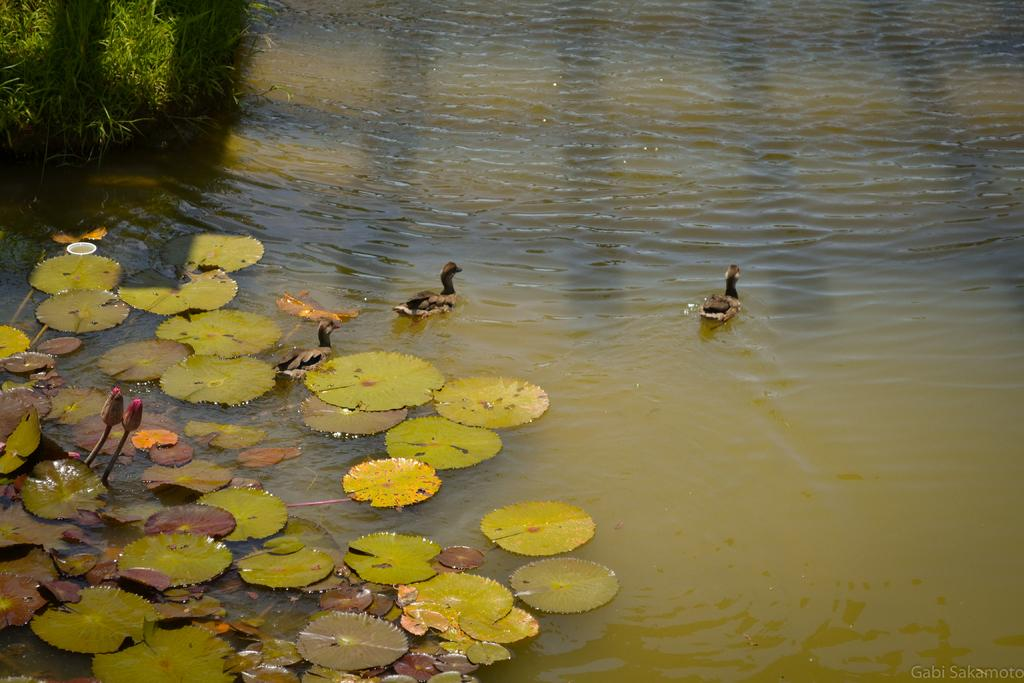What type of animals can be seen in the image? There are ducks in the water in the image. What else can be seen floating on the water? There are leaves and flower buds on the water. What type of vegetation is visible in the image? There is grass visible in the image. Is there any text or logo visible on the image? Yes, the image has a watermark. What type of advice can be seen written on the bike in the image? There is no bike present in the image, so no advice can be seen written on it. 